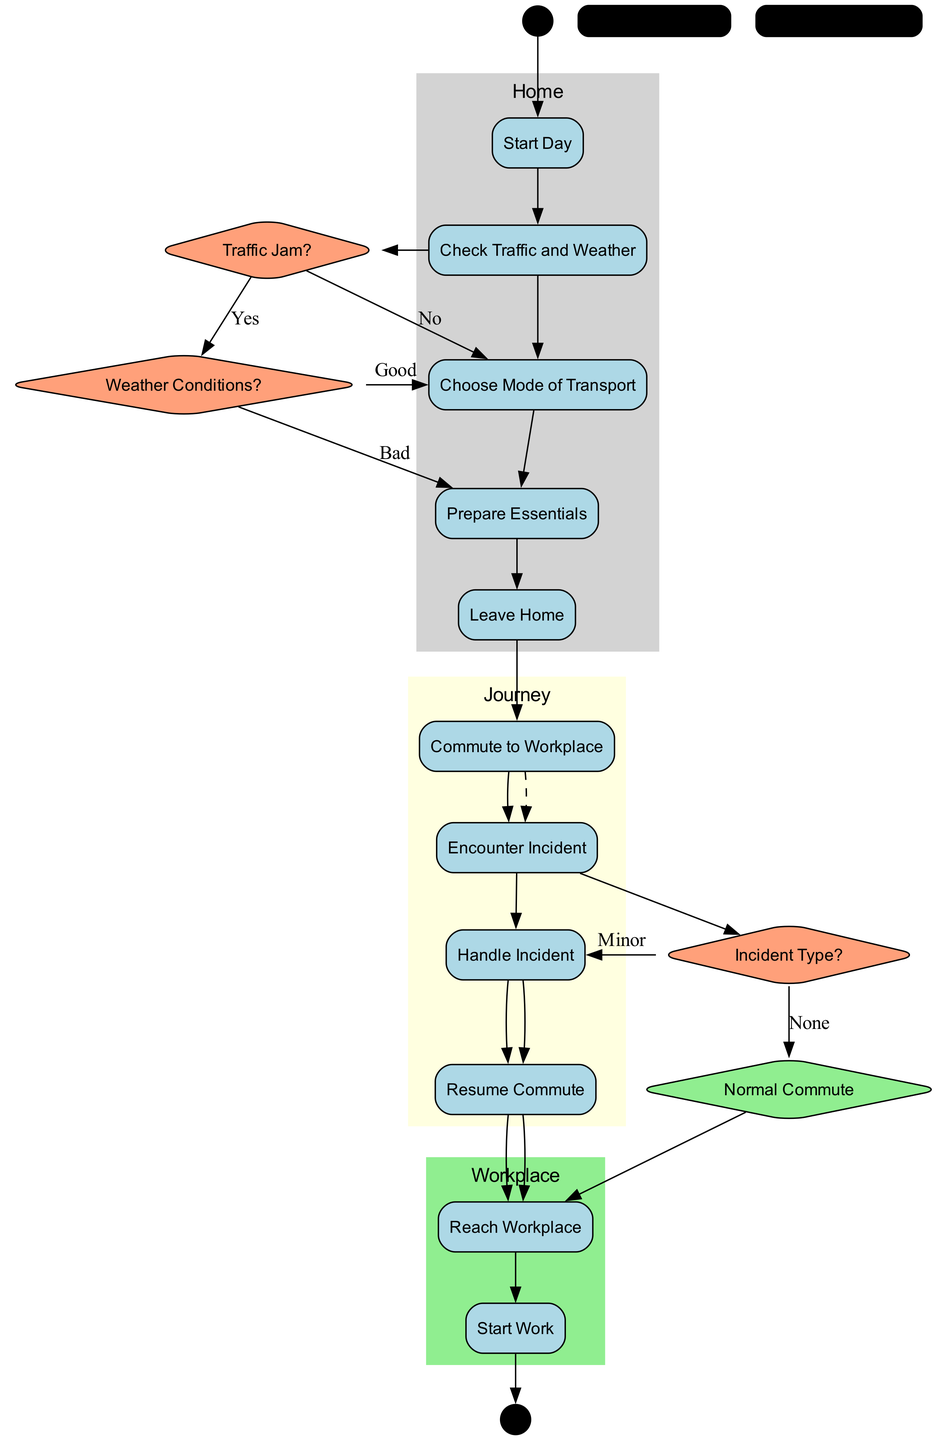What is the first activity in the diagram? The first activity listed in the "activities" section of the data is "Start Day," which is also represented as the first node connected to the start node.
Answer: Start Day How many swimlanes are present in the diagram? There are three swimlanes defined in the "swimlanes" section: Home, Journey, and Workplace, as indicated by the distinct labels and responsibilities included in the diagram.
Answer: 3 What is the last activity before starting work? The activity directly preceding "Start Work" is "Reach Workplace," which is shown as the final step before entering the workplace activities.
Answer: Reach Workplace What happens if there is a traffic jam? If there is a traffic jam, the flow goes from "Traffic Jam?" to "Weather Conditions?" as a part of the decision-making process.
Answer: Weather Conditions? What is the decision node related to incident types? The decision node regarding the incident types is named "Incident Type?" which branches the flow based on the type of incident encountered during the commute.
Answer: Incident Type? In which swimlane does "Leave Home" reside? "Leave Home" is one of the responsibilities listed in the "Home" swimlane, indicating that it is part of the activities performed at home.
Answer: Home What should be done after encountering an incident? After encountering an incident, the next step is to handle the incident, as indicated by the flow from "Encounter Incident" to "Handle Incident."
Answer: Handle Incident How many decisions are made during the commute process? The diagram specifies three decision nodes: "Traffic Jam?", "Weather Conditions?", and "Incident Type?", indicating three separate decision points during the commute.
Answer: 3 What is the consequence of handling an incident? Handling an incident leads to the next activity being "Resume Commute," which indicates the process of continuing the journey after addressing the incident.
Answer: Resume Commute 